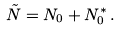Convert formula to latex. <formula><loc_0><loc_0><loc_500><loc_500>\tilde { N } = N _ { 0 } + N _ { 0 } ^ { * } \, .</formula> 